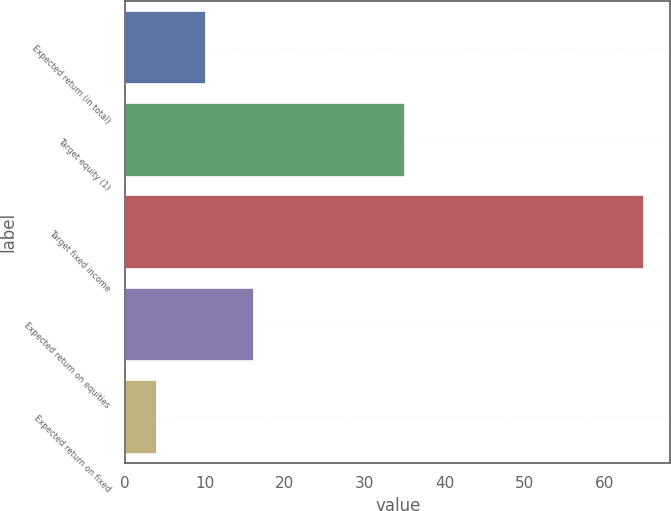<chart> <loc_0><loc_0><loc_500><loc_500><bar_chart><fcel>Expected return (in total)<fcel>Target equity (1)<fcel>Target fixed income<fcel>Expected return on equities<fcel>Expected return on fixed<nl><fcel>10.1<fcel>35<fcel>65<fcel>16.2<fcel>4<nl></chart> 